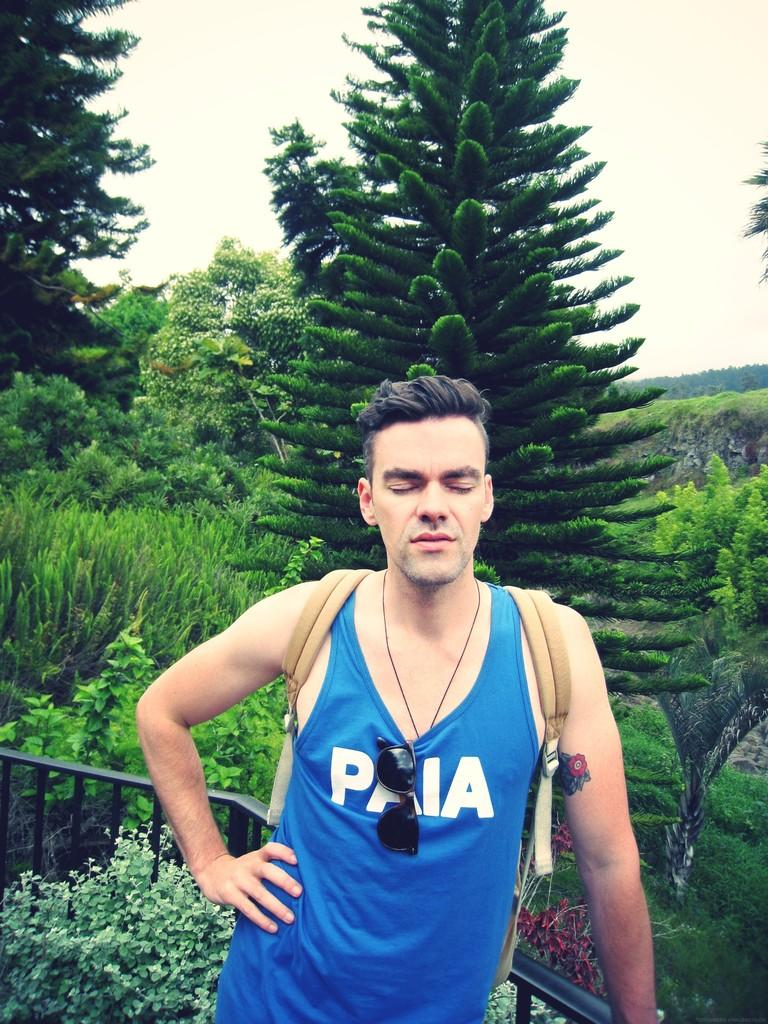<image>
Relay a brief, clear account of the picture shown. A man wearing a blue Paia shirt is standing with his back to an incredible view of large trees with his eyes closed and his hand on his hip. 